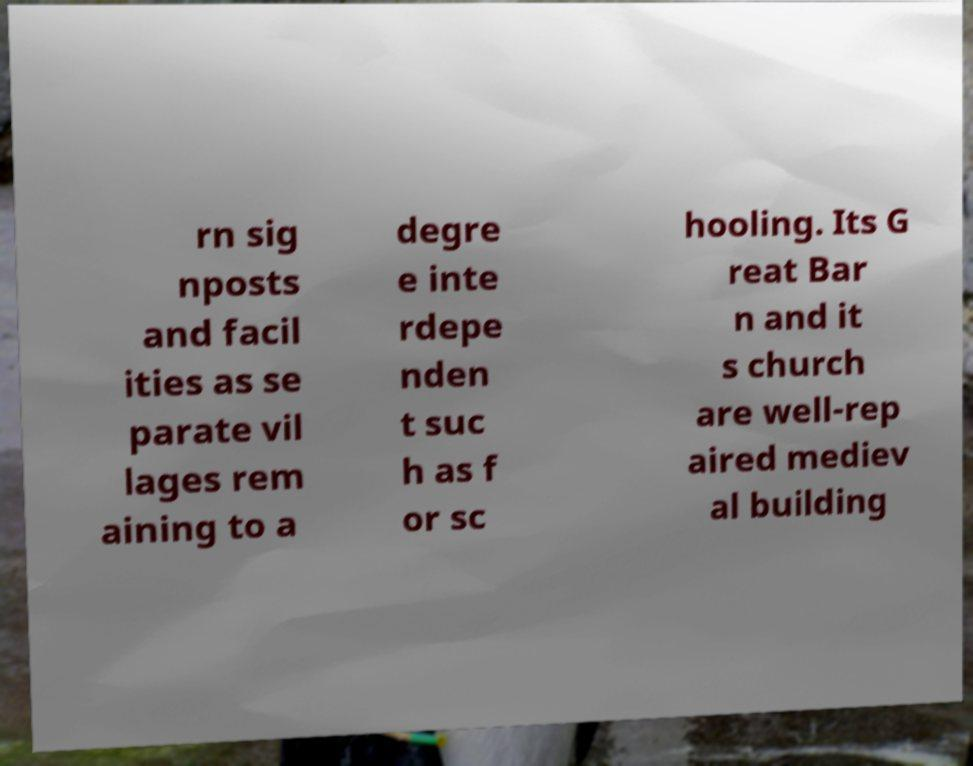There's text embedded in this image that I need extracted. Can you transcribe it verbatim? rn sig nposts and facil ities as se parate vil lages rem aining to a degre e inte rdepe nden t suc h as f or sc hooling. Its G reat Bar n and it s church are well-rep aired mediev al building 